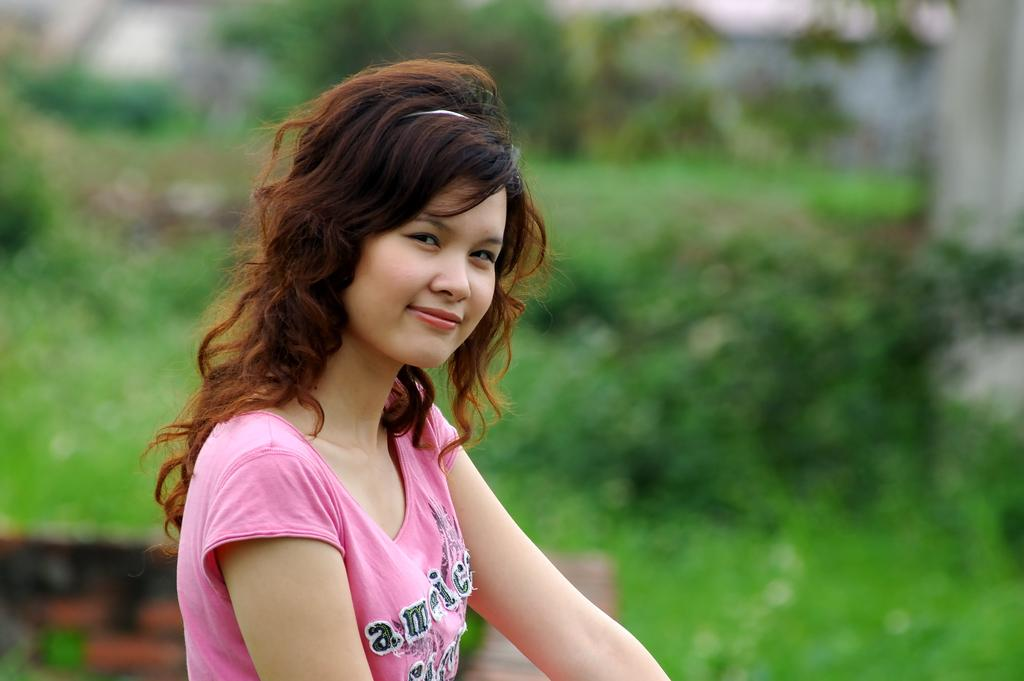Who is present in the image? There is a woman in the image. What is the woman doing in the image? The woman is looking at the side. What can be seen in the background of the image? There are trees visible at the back side of the image. Where is the lunchroom located in the image? There is no mention of a lunchroom in the image, so it cannot be located. 